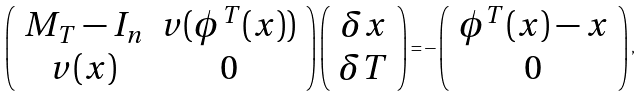Convert formula to latex. <formula><loc_0><loc_0><loc_500><loc_500>\left ( \begin{array} { c c } M _ { T } - I _ { n } & v ( \phi ^ { T } ( x ) ) \\ v ( x ) & 0 \\ \end{array} \right ) \left ( \begin{array} { c } \delta x \\ \delta T \\ \end{array} \right ) = - \left ( \begin{array} { c } \phi ^ { T } ( x ) - x \\ 0 \\ \end{array} \right ) ,</formula> 